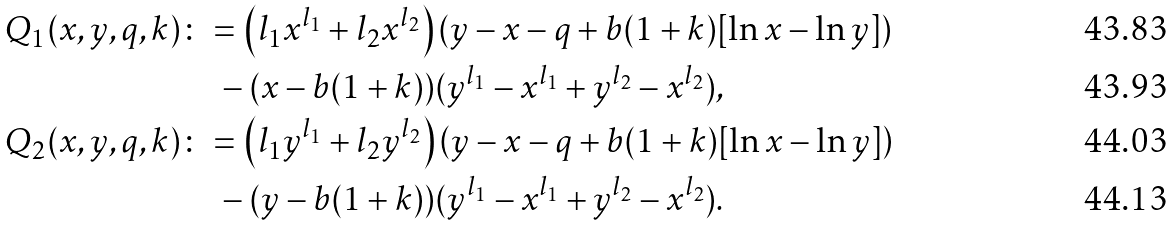Convert formula to latex. <formula><loc_0><loc_0><loc_500><loc_500>Q _ { 1 } ( x , y , q , k ) & \colon = \left ( l _ { 1 } x ^ { l _ { 1 } } + l _ { 2 } x ^ { l _ { 2 } } \right ) \left ( y - x - q + b ( 1 + k ) [ \ln { x } - \ln { y } ] \right ) \\ & \quad - ( x - b ( 1 + k ) ) ( y ^ { l _ { 1 } } - x ^ { l _ { 1 } } + y ^ { l _ { 2 } } - x ^ { l _ { 2 } } ) , \\ Q _ { 2 } ( x , y , q , k ) & \colon = \left ( l _ { 1 } y ^ { l _ { 1 } } + l _ { 2 } y ^ { l _ { 2 } } \right ) \left ( y - x - q + b ( 1 + k ) [ \ln { x } - \ln { y } ] \right ) \\ & \quad - ( y - b ( 1 + k ) ) ( y ^ { l _ { 1 } } - x ^ { l _ { 1 } } + y ^ { l _ { 2 } } - x ^ { l _ { 2 } } ) .</formula> 